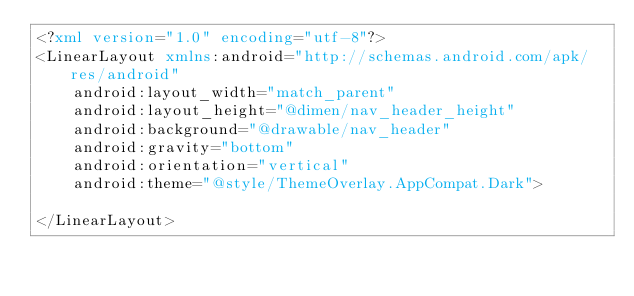<code> <loc_0><loc_0><loc_500><loc_500><_XML_><?xml version="1.0" encoding="utf-8"?>
<LinearLayout xmlns:android="http://schemas.android.com/apk/res/android"
    android:layout_width="match_parent"
    android:layout_height="@dimen/nav_header_height"
    android:background="@drawable/nav_header"
    android:gravity="bottom"
    android:orientation="vertical"
    android:theme="@style/ThemeOverlay.AppCompat.Dark">

</LinearLayout>
</code> 